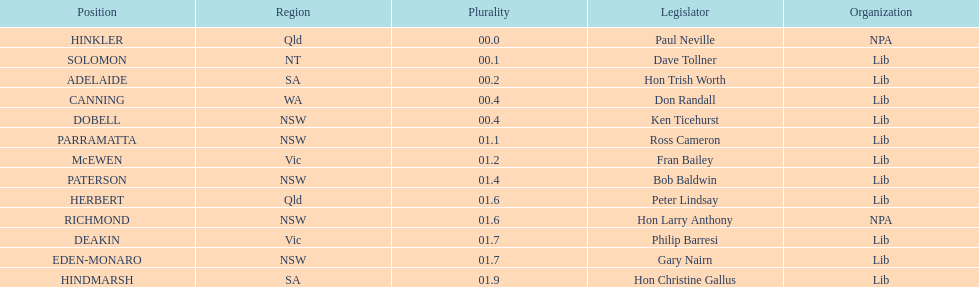Tell me the number of seats from nsw? 5. 